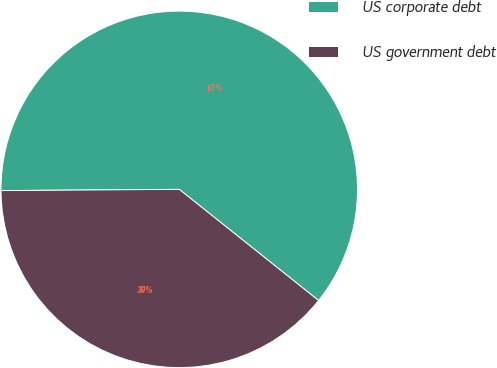Convert chart to OTSL. <chart><loc_0><loc_0><loc_500><loc_500><pie_chart><fcel>US corporate debt<fcel>US government debt<nl><fcel>60.83%<fcel>39.17%<nl></chart> 